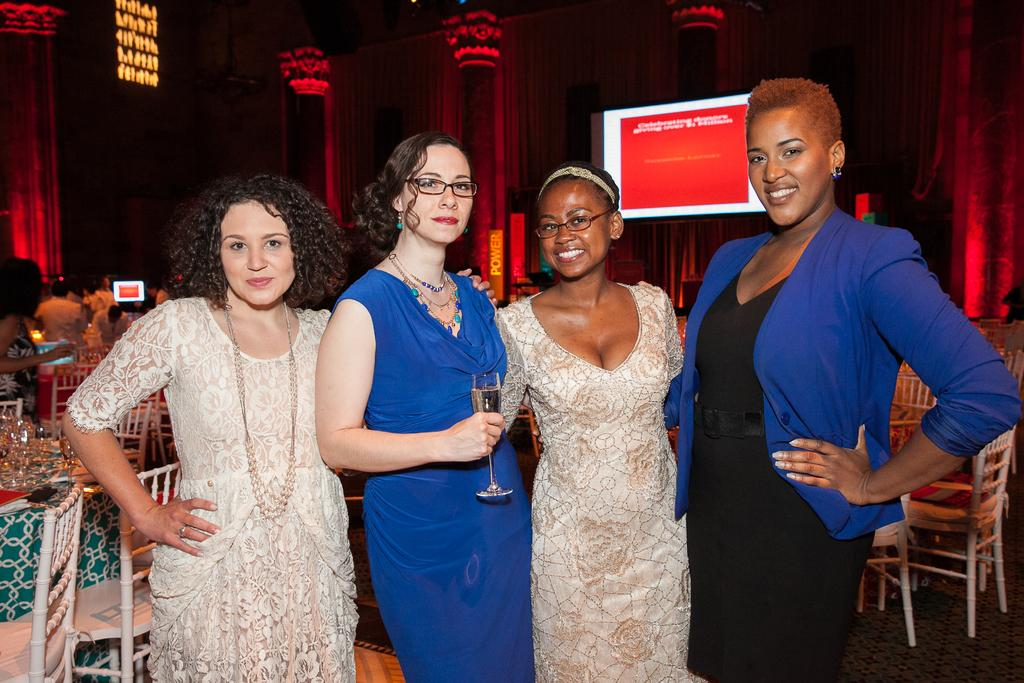How many people are present in the image? There are four people standing in the image. What is one person holding in the image? One person is holding a glass. What can be seen in the background of the image? There are pillars, chairs, objects on tables, a screen, and curtains in the background of the image. What type of ornament is hanging from the ceiling in the image? There is no ornament hanging from the ceiling in the image. Can you see any cats in the image? There are no cats present in the image. 